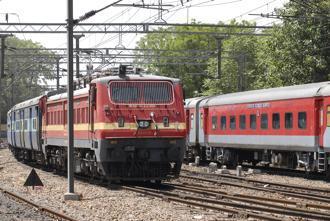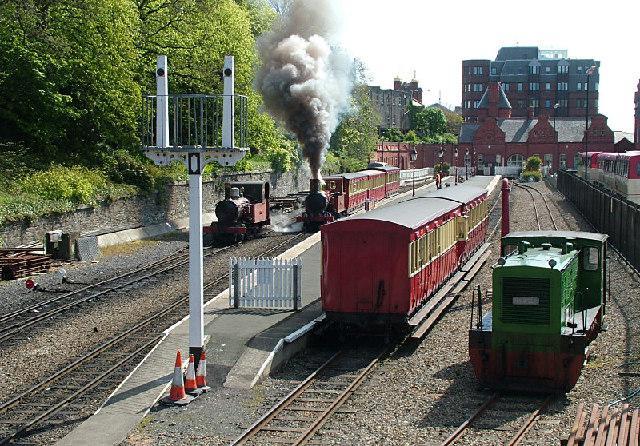The first image is the image on the left, the second image is the image on the right. Considering the images on both sides, is "All the trains depicted feature green coloring." valid? Answer yes or no. No. 